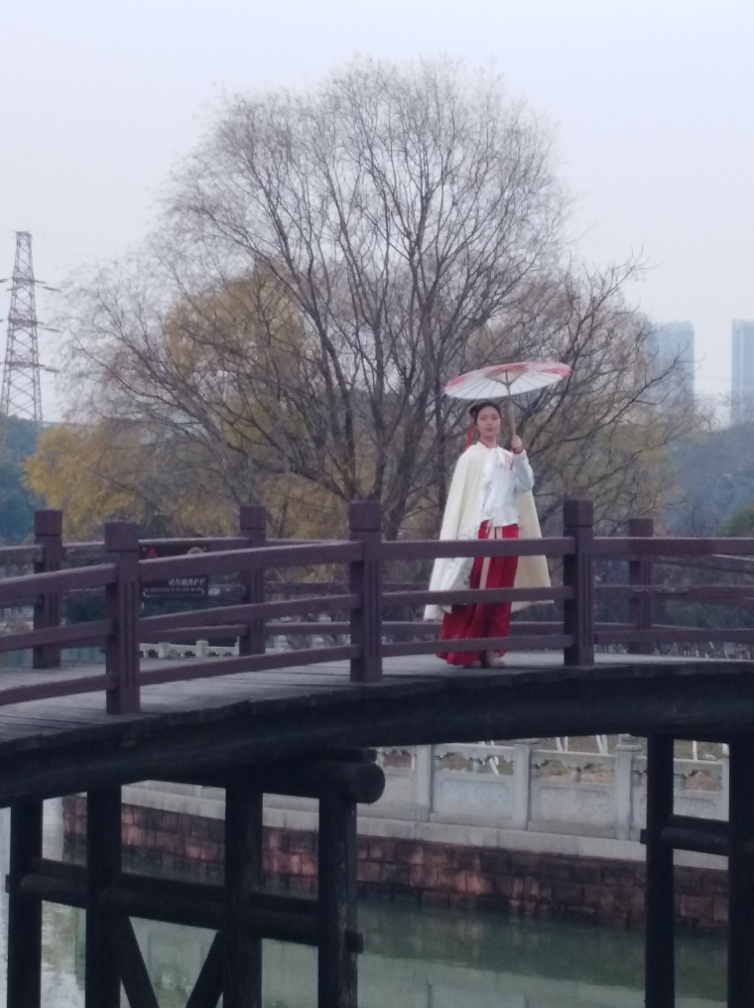Are the texture details of the wooden bridge rich? Yes, the wooden bridge exhibits rich texture details, which can be observed in the varying grain patterns and the natural wear that contributes to its rustic appeal. The texture is accentuated by the contrast between the wood's dark tones and the surrounding lighter elements, such as the water and the railing. 